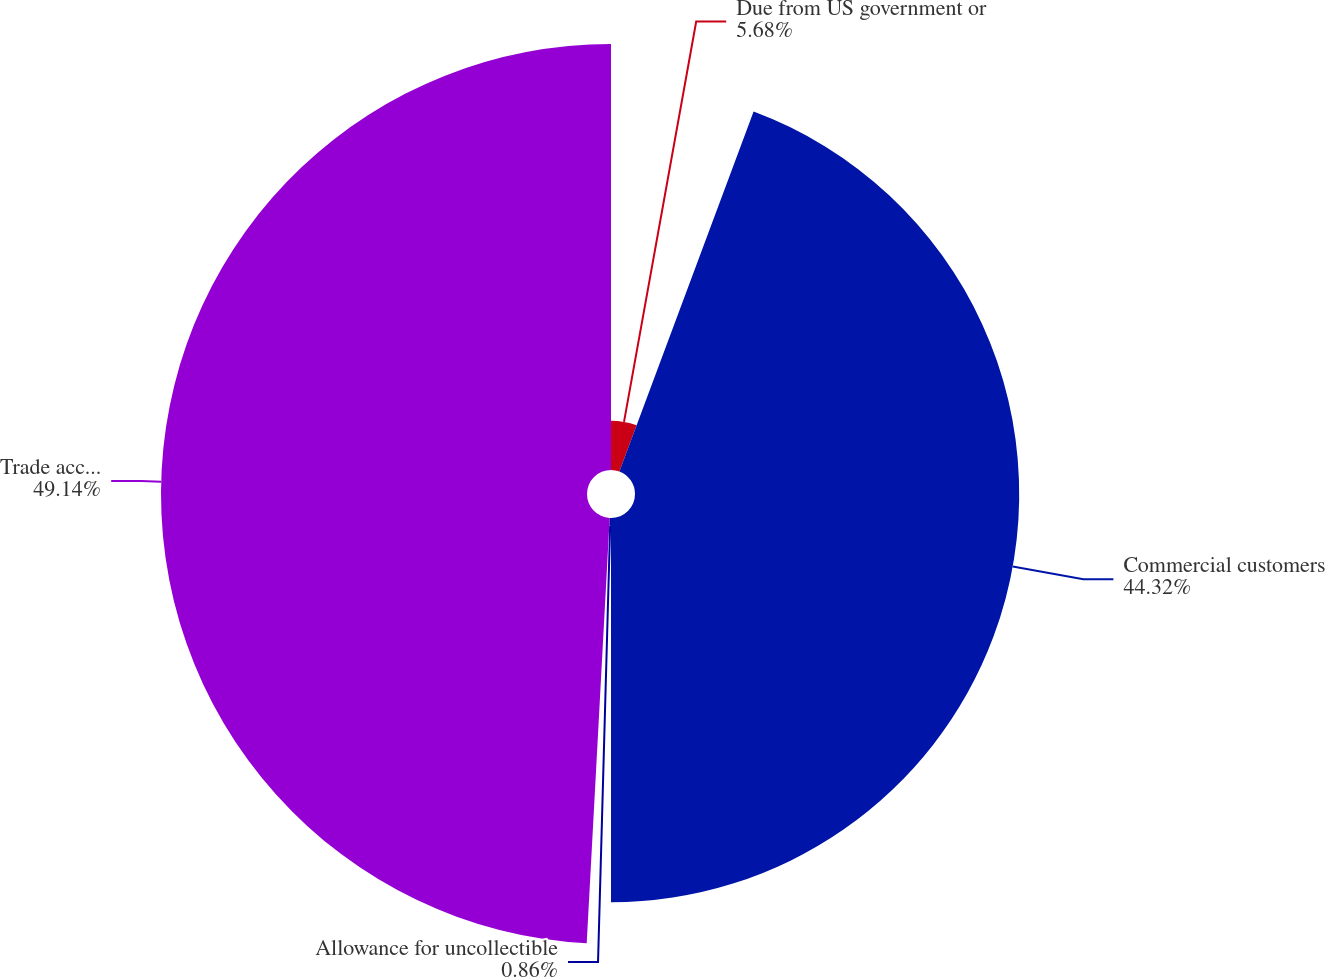<chart> <loc_0><loc_0><loc_500><loc_500><pie_chart><fcel>Due from US government or<fcel>Commercial customers<fcel>Allowance for uncollectible<fcel>Trade accounts receivable-net<nl><fcel>5.68%<fcel>44.32%<fcel>0.86%<fcel>49.14%<nl></chart> 